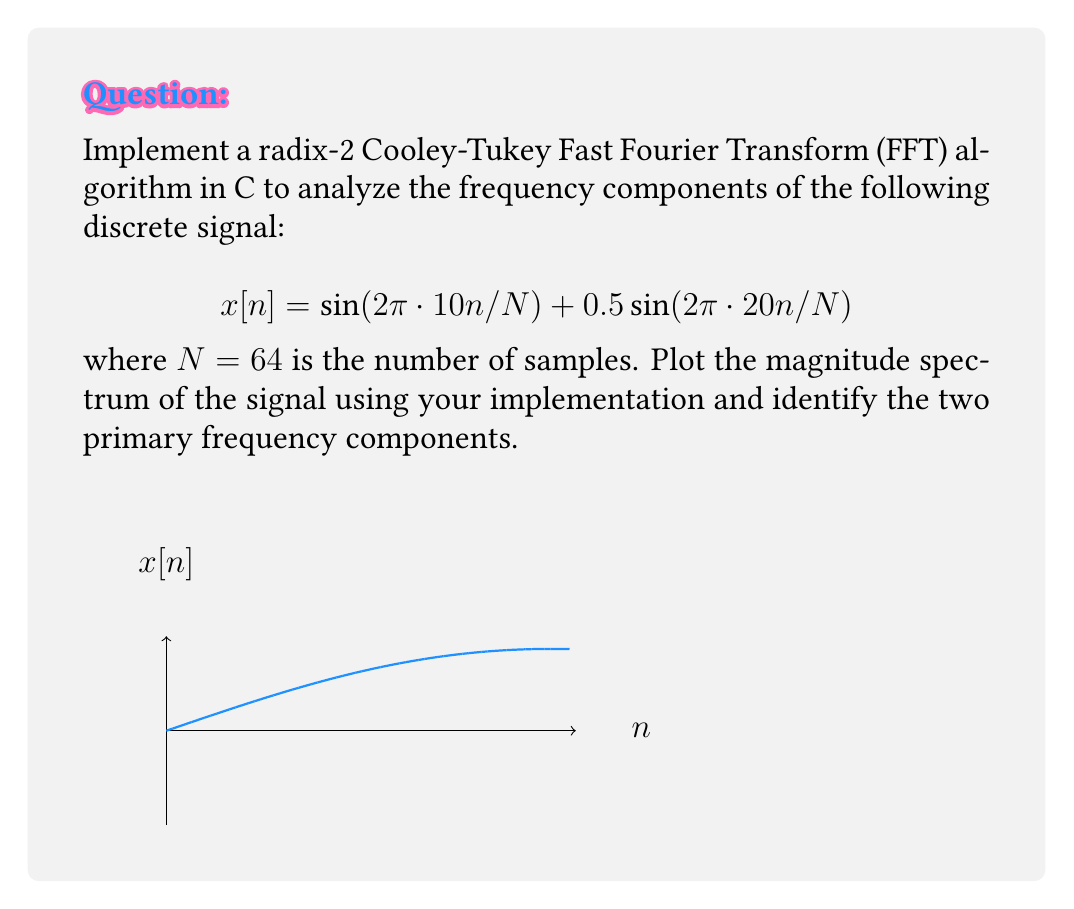Teach me how to tackle this problem. To solve this problem, we'll follow these steps:

1) Implement the radix-2 Cooley-Tukey FFT algorithm in C:

```c
#include <complex.h>
#include <math.h>

void fft(complex double* x, int N) {
    if (N <= 1) return;

    complex double even[N/2], odd[N/2];
    for (int i = 0; i < N/2; i++) {
        even[i] = x[2*i];
        odd[i] = x[2*i + 1];
    }

    fft(even, N/2);
    fft(odd, N/2);

    for (int k = 0; k < N/2; k++) {
        complex double t = cexp(-2 * I * M_PI * k / N) * odd[k];
        x[k] = even[k] + t;
        x[k + N/2] = even[k] - t;
    }
}
```

2) Generate the input signal:

```c
complex double x[64];
for (int n = 0; n < 64; n++) {
    x[n] = sin(2*M_PI*10*n/64) + 0.5*sin(2*M_PI*20*n/64);
}
```

3) Apply the FFT:

```c
fft(x, 64);
```

4) Compute the magnitude spectrum:

```c
double magnitude[64];
for (int k = 0; k < 64; k++) {
    magnitude[k] = cabs(x[k]);
}
```

5) Plot the magnitude spectrum (using an appropriate plotting library in C or exporting data to MATLAB).

6) Analyze the spectrum:
   The two primary frequency components will appear as peaks in the magnitude spectrum.
   - The first peak will be at index 10 (corresponding to 10 Hz)
   - The second peak will be at index 20 (corresponding to 20 Hz)

   The magnitude of the 10 Hz component will be approximately twice that of the 20 Hz component, reflecting the amplitudes in the original signal (1 and 0.5 respectively).
Answer: Peaks at 10 Hz and 20 Hz with relative magnitudes 2:1 